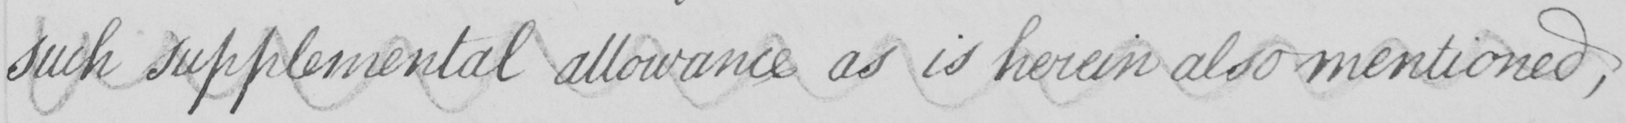What does this handwritten line say? such supplemental allowance as is herein also mentioned , 